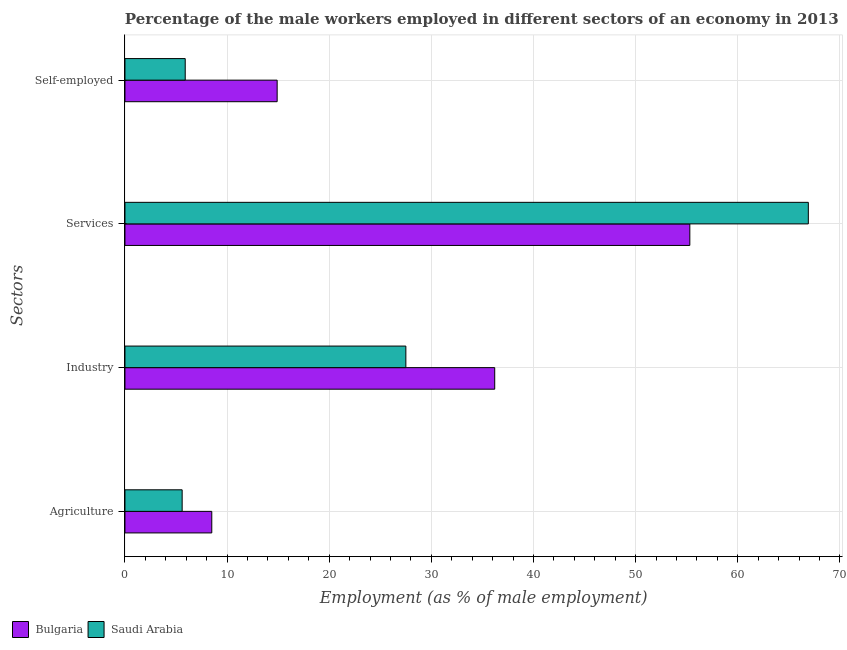How many groups of bars are there?
Provide a short and direct response. 4. How many bars are there on the 3rd tick from the bottom?
Provide a succinct answer. 2. What is the label of the 4th group of bars from the top?
Make the answer very short. Agriculture. What is the percentage of male workers in industry in Bulgaria?
Your response must be concise. 36.2. Across all countries, what is the minimum percentage of self employed male workers?
Make the answer very short. 5.9. In which country was the percentage of self employed male workers maximum?
Your answer should be compact. Bulgaria. In which country was the percentage of male workers in agriculture minimum?
Give a very brief answer. Saudi Arabia. What is the total percentage of male workers in industry in the graph?
Give a very brief answer. 63.7. What is the difference between the percentage of male workers in services in Bulgaria and that in Saudi Arabia?
Offer a very short reply. -11.6. What is the difference between the percentage of male workers in industry in Bulgaria and the percentage of male workers in services in Saudi Arabia?
Keep it short and to the point. -30.7. What is the average percentage of self employed male workers per country?
Your answer should be very brief. 10.4. What is the difference between the percentage of self employed male workers and percentage of male workers in agriculture in Saudi Arabia?
Provide a succinct answer. 0.3. What is the ratio of the percentage of male workers in services in Bulgaria to that in Saudi Arabia?
Make the answer very short. 0.83. Is the percentage of male workers in services in Saudi Arabia less than that in Bulgaria?
Offer a very short reply. No. What is the difference between the highest and the second highest percentage of male workers in agriculture?
Your answer should be very brief. 2.9. What is the difference between the highest and the lowest percentage of male workers in industry?
Offer a very short reply. 8.7. Is it the case that in every country, the sum of the percentage of male workers in services and percentage of male workers in industry is greater than the sum of percentage of self employed male workers and percentage of male workers in agriculture?
Your answer should be compact. Yes. What does the 1st bar from the bottom in Industry represents?
Ensure brevity in your answer.  Bulgaria. Is it the case that in every country, the sum of the percentage of male workers in agriculture and percentage of male workers in industry is greater than the percentage of male workers in services?
Give a very brief answer. No. How many bars are there?
Your response must be concise. 8. Are all the bars in the graph horizontal?
Provide a succinct answer. Yes. How many countries are there in the graph?
Provide a succinct answer. 2. What is the title of the graph?
Provide a short and direct response. Percentage of the male workers employed in different sectors of an economy in 2013. Does "Caribbean small states" appear as one of the legend labels in the graph?
Keep it short and to the point. No. What is the label or title of the X-axis?
Your answer should be very brief. Employment (as % of male employment). What is the label or title of the Y-axis?
Your answer should be very brief. Sectors. What is the Employment (as % of male employment) of Bulgaria in Agriculture?
Ensure brevity in your answer.  8.5. What is the Employment (as % of male employment) of Saudi Arabia in Agriculture?
Offer a very short reply. 5.6. What is the Employment (as % of male employment) of Bulgaria in Industry?
Your answer should be compact. 36.2. What is the Employment (as % of male employment) in Saudi Arabia in Industry?
Offer a terse response. 27.5. What is the Employment (as % of male employment) in Bulgaria in Services?
Keep it short and to the point. 55.3. What is the Employment (as % of male employment) in Saudi Arabia in Services?
Your answer should be very brief. 66.9. What is the Employment (as % of male employment) in Bulgaria in Self-employed?
Offer a terse response. 14.9. What is the Employment (as % of male employment) in Saudi Arabia in Self-employed?
Give a very brief answer. 5.9. Across all Sectors, what is the maximum Employment (as % of male employment) in Bulgaria?
Your answer should be compact. 55.3. Across all Sectors, what is the maximum Employment (as % of male employment) of Saudi Arabia?
Offer a very short reply. 66.9. Across all Sectors, what is the minimum Employment (as % of male employment) of Saudi Arabia?
Your answer should be very brief. 5.6. What is the total Employment (as % of male employment) in Bulgaria in the graph?
Keep it short and to the point. 114.9. What is the total Employment (as % of male employment) of Saudi Arabia in the graph?
Your answer should be very brief. 105.9. What is the difference between the Employment (as % of male employment) of Bulgaria in Agriculture and that in Industry?
Give a very brief answer. -27.7. What is the difference between the Employment (as % of male employment) in Saudi Arabia in Agriculture and that in Industry?
Make the answer very short. -21.9. What is the difference between the Employment (as % of male employment) in Bulgaria in Agriculture and that in Services?
Your response must be concise. -46.8. What is the difference between the Employment (as % of male employment) of Saudi Arabia in Agriculture and that in Services?
Offer a terse response. -61.3. What is the difference between the Employment (as % of male employment) in Saudi Arabia in Agriculture and that in Self-employed?
Your answer should be compact. -0.3. What is the difference between the Employment (as % of male employment) of Bulgaria in Industry and that in Services?
Give a very brief answer. -19.1. What is the difference between the Employment (as % of male employment) of Saudi Arabia in Industry and that in Services?
Make the answer very short. -39.4. What is the difference between the Employment (as % of male employment) of Bulgaria in Industry and that in Self-employed?
Make the answer very short. 21.3. What is the difference between the Employment (as % of male employment) of Saudi Arabia in Industry and that in Self-employed?
Your response must be concise. 21.6. What is the difference between the Employment (as % of male employment) of Bulgaria in Services and that in Self-employed?
Your answer should be compact. 40.4. What is the difference between the Employment (as % of male employment) of Saudi Arabia in Services and that in Self-employed?
Offer a terse response. 61. What is the difference between the Employment (as % of male employment) in Bulgaria in Agriculture and the Employment (as % of male employment) in Saudi Arabia in Services?
Ensure brevity in your answer.  -58.4. What is the difference between the Employment (as % of male employment) in Bulgaria in Agriculture and the Employment (as % of male employment) in Saudi Arabia in Self-employed?
Your answer should be compact. 2.6. What is the difference between the Employment (as % of male employment) in Bulgaria in Industry and the Employment (as % of male employment) in Saudi Arabia in Services?
Give a very brief answer. -30.7. What is the difference between the Employment (as % of male employment) of Bulgaria in Industry and the Employment (as % of male employment) of Saudi Arabia in Self-employed?
Offer a terse response. 30.3. What is the difference between the Employment (as % of male employment) in Bulgaria in Services and the Employment (as % of male employment) in Saudi Arabia in Self-employed?
Offer a terse response. 49.4. What is the average Employment (as % of male employment) in Bulgaria per Sectors?
Offer a very short reply. 28.73. What is the average Employment (as % of male employment) in Saudi Arabia per Sectors?
Make the answer very short. 26.48. What is the difference between the Employment (as % of male employment) in Bulgaria and Employment (as % of male employment) in Saudi Arabia in Industry?
Give a very brief answer. 8.7. What is the difference between the Employment (as % of male employment) of Bulgaria and Employment (as % of male employment) of Saudi Arabia in Services?
Provide a short and direct response. -11.6. What is the difference between the Employment (as % of male employment) in Bulgaria and Employment (as % of male employment) in Saudi Arabia in Self-employed?
Make the answer very short. 9. What is the ratio of the Employment (as % of male employment) of Bulgaria in Agriculture to that in Industry?
Keep it short and to the point. 0.23. What is the ratio of the Employment (as % of male employment) in Saudi Arabia in Agriculture to that in Industry?
Offer a very short reply. 0.2. What is the ratio of the Employment (as % of male employment) in Bulgaria in Agriculture to that in Services?
Provide a short and direct response. 0.15. What is the ratio of the Employment (as % of male employment) of Saudi Arabia in Agriculture to that in Services?
Your response must be concise. 0.08. What is the ratio of the Employment (as % of male employment) in Bulgaria in Agriculture to that in Self-employed?
Ensure brevity in your answer.  0.57. What is the ratio of the Employment (as % of male employment) of Saudi Arabia in Agriculture to that in Self-employed?
Provide a succinct answer. 0.95. What is the ratio of the Employment (as % of male employment) of Bulgaria in Industry to that in Services?
Your response must be concise. 0.65. What is the ratio of the Employment (as % of male employment) in Saudi Arabia in Industry to that in Services?
Ensure brevity in your answer.  0.41. What is the ratio of the Employment (as % of male employment) of Bulgaria in Industry to that in Self-employed?
Your answer should be compact. 2.43. What is the ratio of the Employment (as % of male employment) in Saudi Arabia in Industry to that in Self-employed?
Your response must be concise. 4.66. What is the ratio of the Employment (as % of male employment) of Bulgaria in Services to that in Self-employed?
Provide a succinct answer. 3.71. What is the ratio of the Employment (as % of male employment) of Saudi Arabia in Services to that in Self-employed?
Your answer should be very brief. 11.34. What is the difference between the highest and the second highest Employment (as % of male employment) in Bulgaria?
Provide a short and direct response. 19.1. What is the difference between the highest and the second highest Employment (as % of male employment) in Saudi Arabia?
Ensure brevity in your answer.  39.4. What is the difference between the highest and the lowest Employment (as % of male employment) of Bulgaria?
Your answer should be compact. 46.8. What is the difference between the highest and the lowest Employment (as % of male employment) in Saudi Arabia?
Your answer should be very brief. 61.3. 